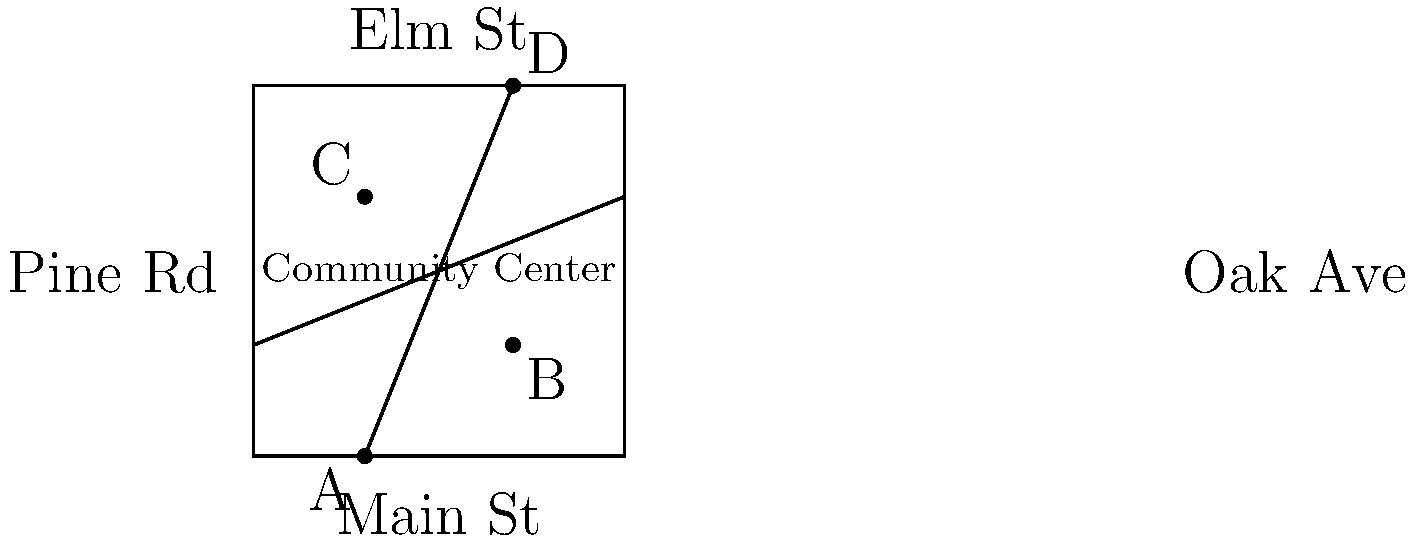As a community organizer planning an event at the Community Center, you're analyzing the neighborhood map. Main St and Elm St are parallel, as are Oak Ave and Pine Rd. If the angle formed by Main St and Oak Ave at point A is 60°, what is the measure of angle BCD? Let's approach this step-by-step:

1) In the given map, we have two pairs of parallel streets:
   - Main St is parallel to Elm St
   - Oak Ave is parallel to Pine Rd

2) The intersection of these streets forms several angles. We're told that angle BAD (formed by Main St and Oak Ave) is 60°.

3) When a transversal (Oak Ave) crosses parallel lines (Main St and Elm St), corresponding angles are congruent. Therefore, angle DCG is also 60°.

4) In a full rotation (360°), we can identify four angles at point C:
   - Angle DCG (which we know is 60°)
   - Angle BCD (which we're trying to find)
   - Two other angles formed by the intersecting streets

5) Since Oak Ave and Pine Rd are parallel, the angle opposite to BCD at point C must be equal to BAD, which is 60°.

6) The sum of angles in a full rotation is 360°. We can set up an equation:
   $60° + 60° + x + x = 360°$
   Where $x$ represents angle BCD.

7) Simplifying the equation:
   $120° + 2x = 360°$
   $2x = 240°$
   $x = 120°$

Therefore, angle BCD measures 120°.
Answer: 120° 